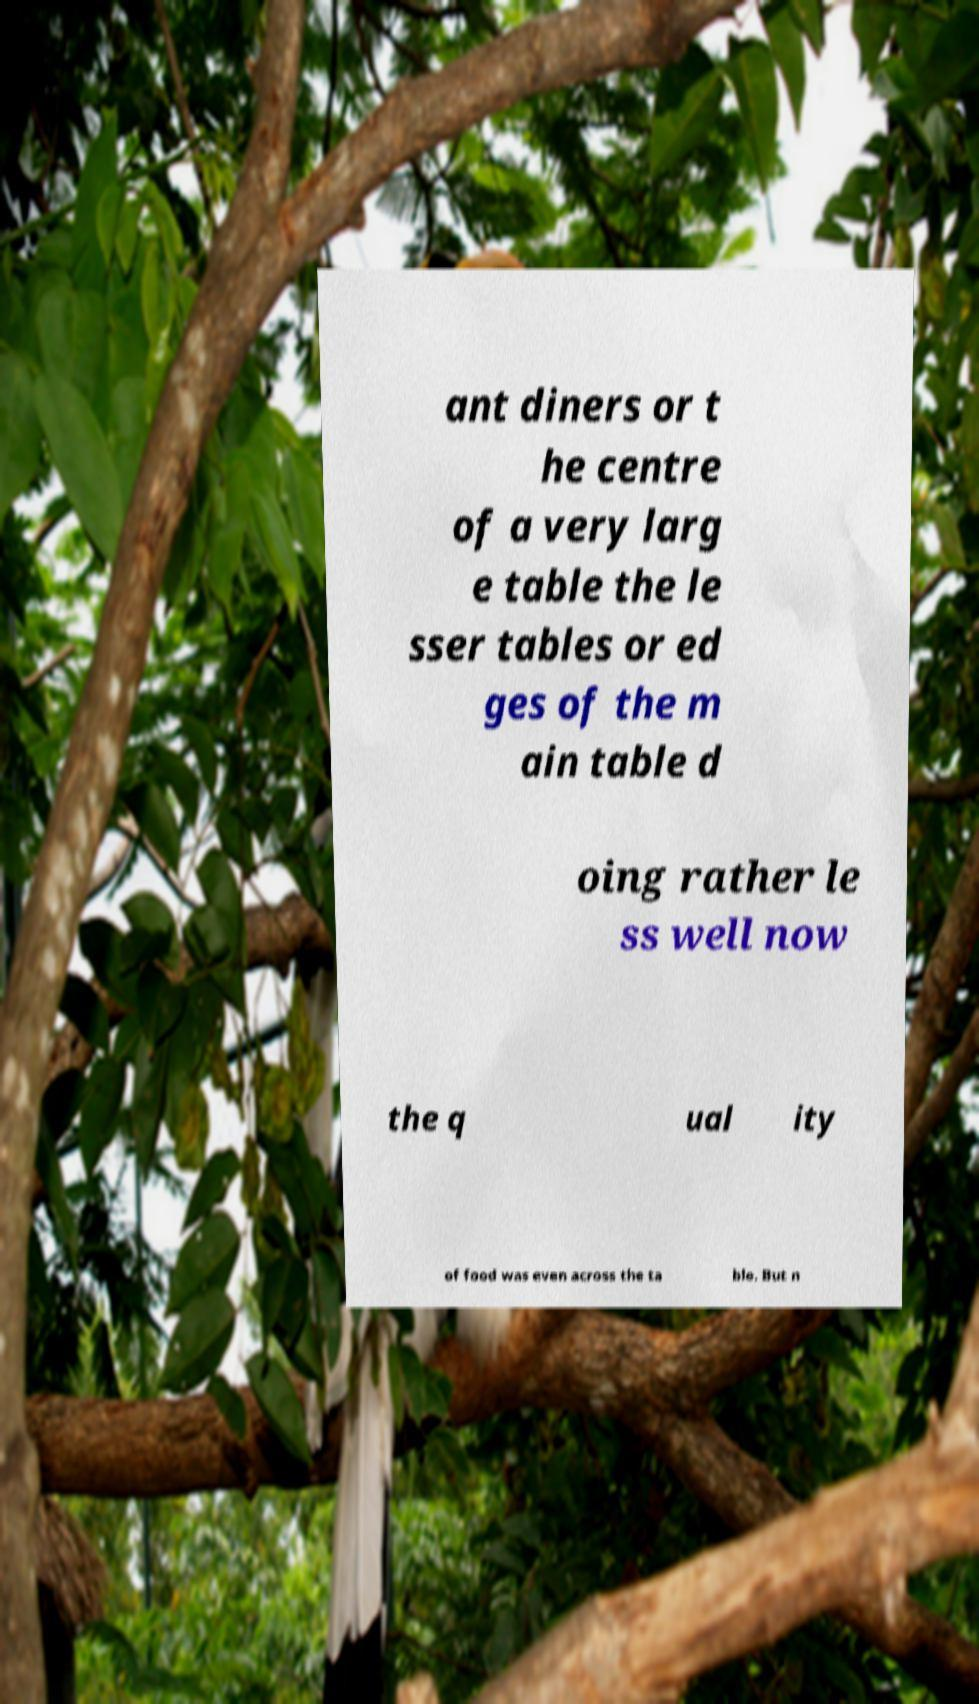Could you extract and type out the text from this image? ant diners or t he centre of a very larg e table the le sser tables or ed ges of the m ain table d oing rather le ss well now the q ual ity of food was even across the ta ble. But n 